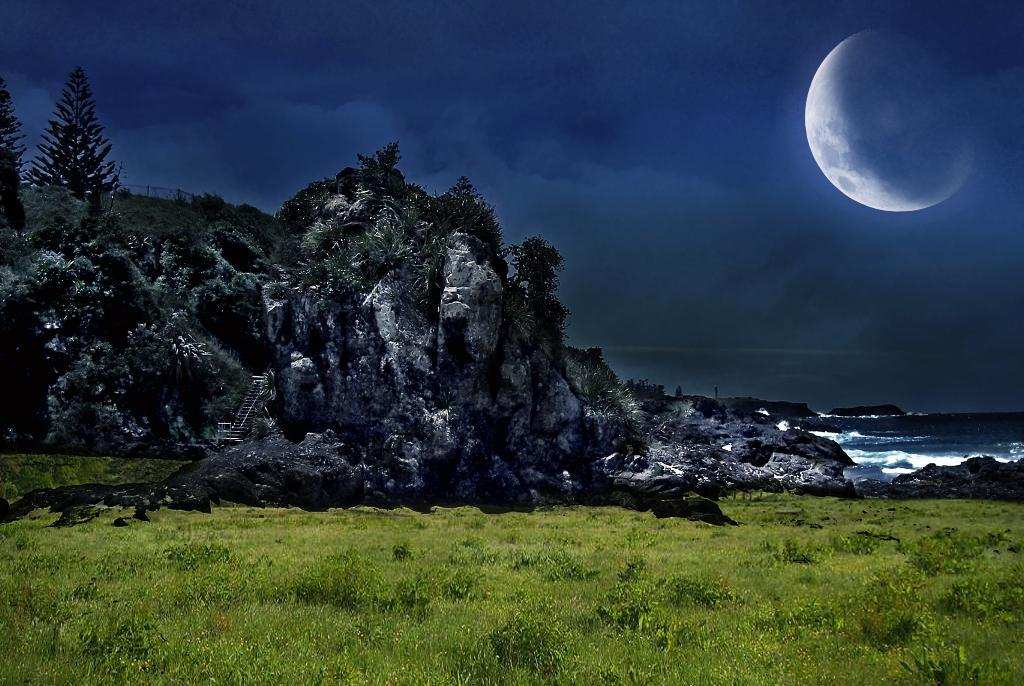What type of surface is visible in the image? There is a grass surface in the image. What other natural features can be seen in the image? There are huge rocks in the image, with plants and trees growing on them. Where is the water surface located in the image? The water surface is on the right side of the image. How does the dock appear in the image? There is no dock present in the image. What type of act is being performed by the plants on the rocks? The plants on the rocks are not performing any act; they are simply growing on the rocks. 